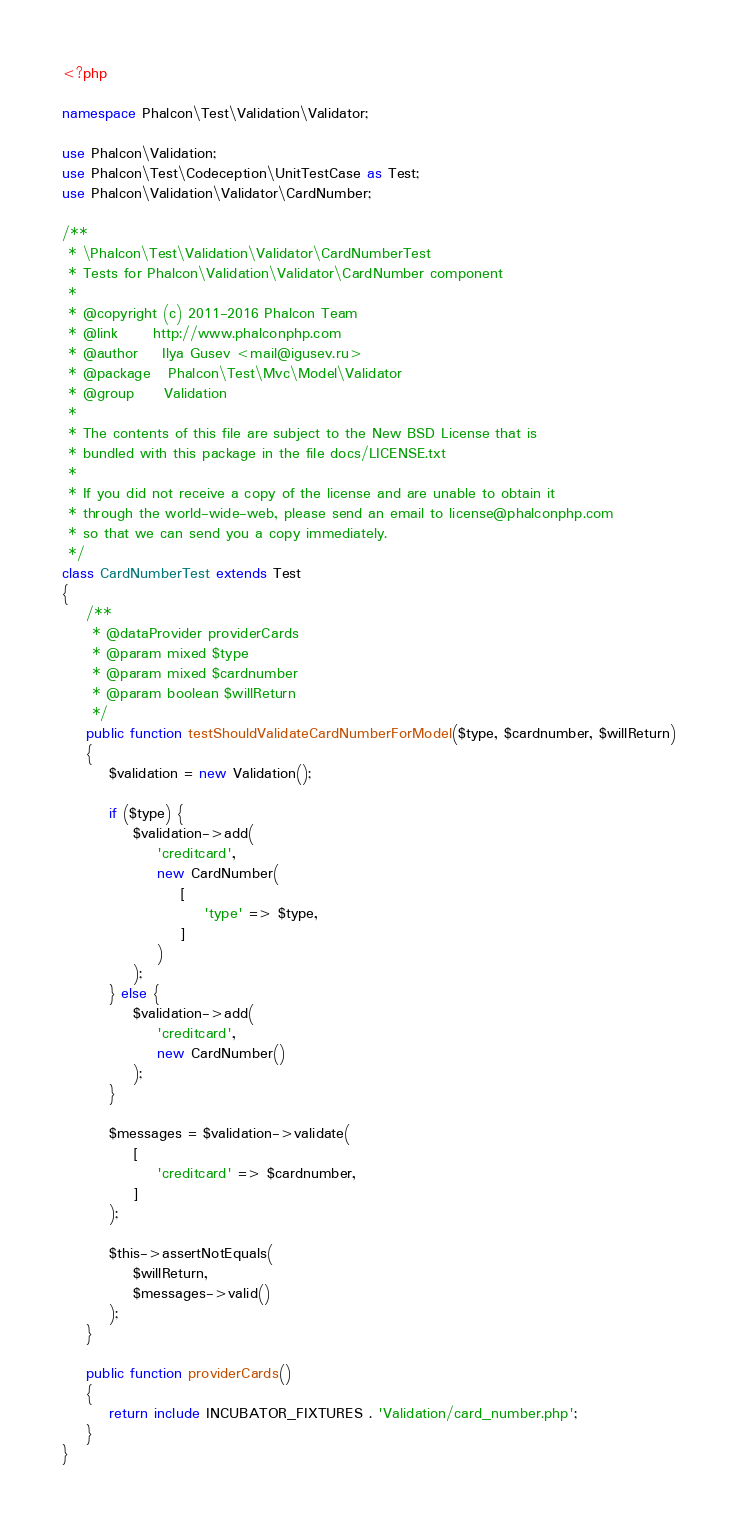Convert code to text. <code><loc_0><loc_0><loc_500><loc_500><_PHP_><?php

namespace Phalcon\Test\Validation\Validator;

use Phalcon\Validation;
use Phalcon\Test\Codeception\UnitTestCase as Test;
use Phalcon\Validation\Validator\CardNumber;

/**
 * \Phalcon\Test\Validation\Validator\CardNumberTest
 * Tests for Phalcon\Validation\Validator\CardNumber component
 *
 * @copyright (c) 2011-2016 Phalcon Team
 * @link      http://www.phalconphp.com
 * @author    Ilya Gusev <mail@igusev.ru>
 * @package   Phalcon\Test\Mvc\Model\Validator
 * @group     Validation
 *
 * The contents of this file are subject to the New BSD License that is
 * bundled with this package in the file docs/LICENSE.txt
 *
 * If you did not receive a copy of the license and are unable to obtain it
 * through the world-wide-web, please send an email to license@phalconphp.com
 * so that we can send you a copy immediately.
 */
class CardNumberTest extends Test
{
    /**
     * @dataProvider providerCards
     * @param mixed $type
     * @param mixed $cardnumber
     * @param boolean $willReturn
     */
    public function testShouldValidateCardNumberForModel($type, $cardnumber, $willReturn)
    {
        $validation = new Validation();

        if ($type) {
            $validation->add(
                'creditcard',
                new CardNumber(
                    [
                        'type' => $type,
                    ]
                )
            );
        } else {
            $validation->add(
                'creditcard',
                new CardNumber()
            );
        }

        $messages = $validation->validate(
            [
                'creditcard' => $cardnumber,
            ]
        );

        $this->assertNotEquals(
            $willReturn,
            $messages->valid()
        );
    }

    public function providerCards()
    {
        return include INCUBATOR_FIXTURES . 'Validation/card_number.php';
    }
}
</code> 